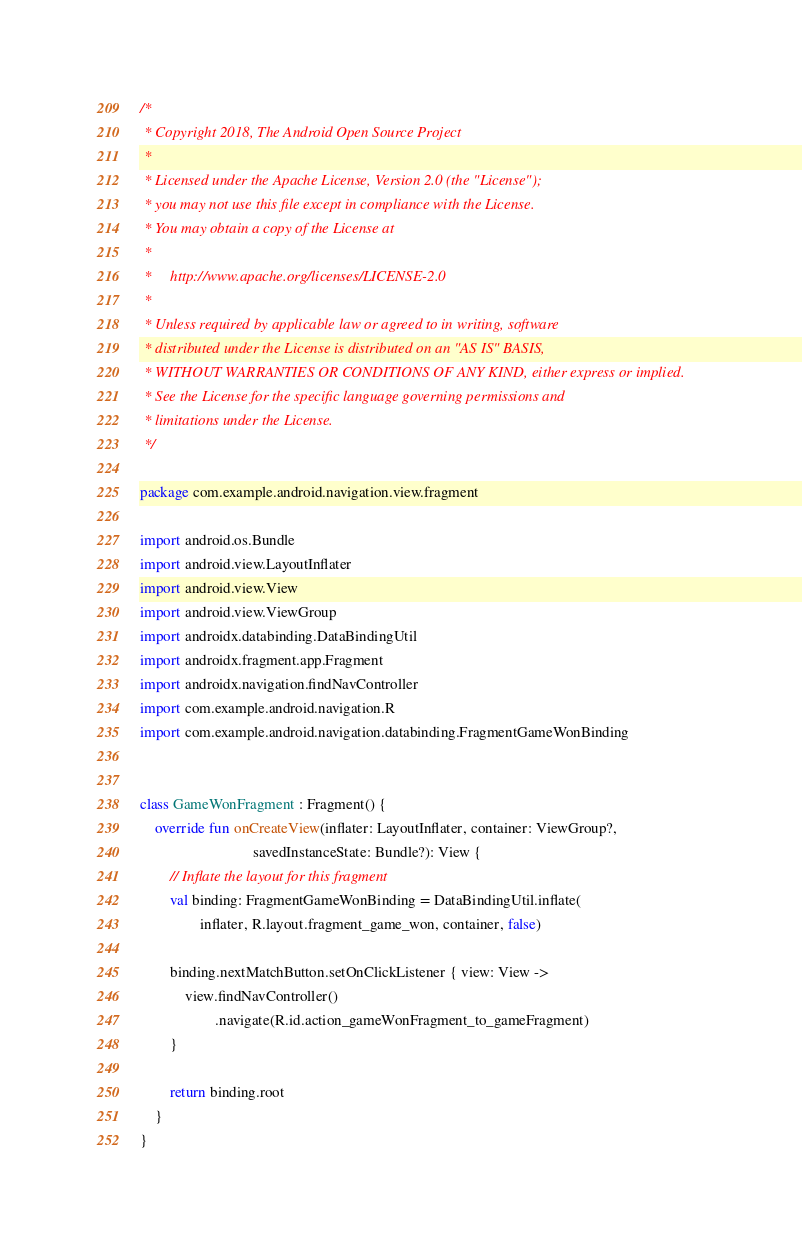<code> <loc_0><loc_0><loc_500><loc_500><_Kotlin_>/*
 * Copyright 2018, The Android Open Source Project
 *
 * Licensed under the Apache License, Version 2.0 (the "License");
 * you may not use this file except in compliance with the License.
 * You may obtain a copy of the License at
 *
 *     http://www.apache.org/licenses/LICENSE-2.0
 *
 * Unless required by applicable law or agreed to in writing, software
 * distributed under the License is distributed on an "AS IS" BASIS,
 * WITHOUT WARRANTIES OR CONDITIONS OF ANY KIND, either express or implied.
 * See the License for the specific language governing permissions and
 * limitations under the License.
 */

package com.example.android.navigation.view.fragment

import android.os.Bundle
import android.view.LayoutInflater
import android.view.View
import android.view.ViewGroup
import androidx.databinding.DataBindingUtil
import androidx.fragment.app.Fragment
import androidx.navigation.findNavController
import com.example.android.navigation.R
import com.example.android.navigation.databinding.FragmentGameWonBinding


class GameWonFragment : Fragment() {
    override fun onCreateView(inflater: LayoutInflater, container: ViewGroup?,
                              savedInstanceState: Bundle?): View {
        // Inflate the layout for this fragment
        val binding: FragmentGameWonBinding = DataBindingUtil.inflate(
                inflater, R.layout.fragment_game_won, container, false)

        binding.nextMatchButton.setOnClickListener { view: View ->
            view.findNavController()
                    .navigate(R.id.action_gameWonFragment_to_gameFragment)
        }

        return binding.root
    }
}
</code> 